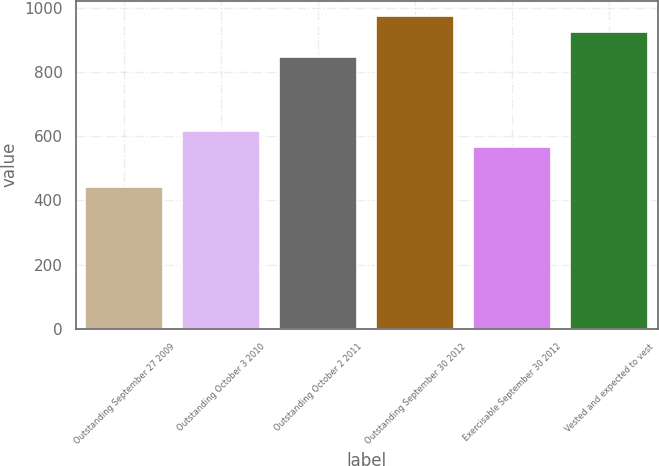Convert chart to OTSL. <chart><loc_0><loc_0><loc_500><loc_500><bar_chart><fcel>Outstanding September 27 2009<fcel>Outstanding October 3 2010<fcel>Outstanding October 2 2011<fcel>Outstanding September 30 2012<fcel>Exercisable September 30 2012<fcel>Vested and expected to vest<nl><fcel>442<fcel>617.3<fcel>848<fcel>973.3<fcel>567<fcel>923<nl></chart> 